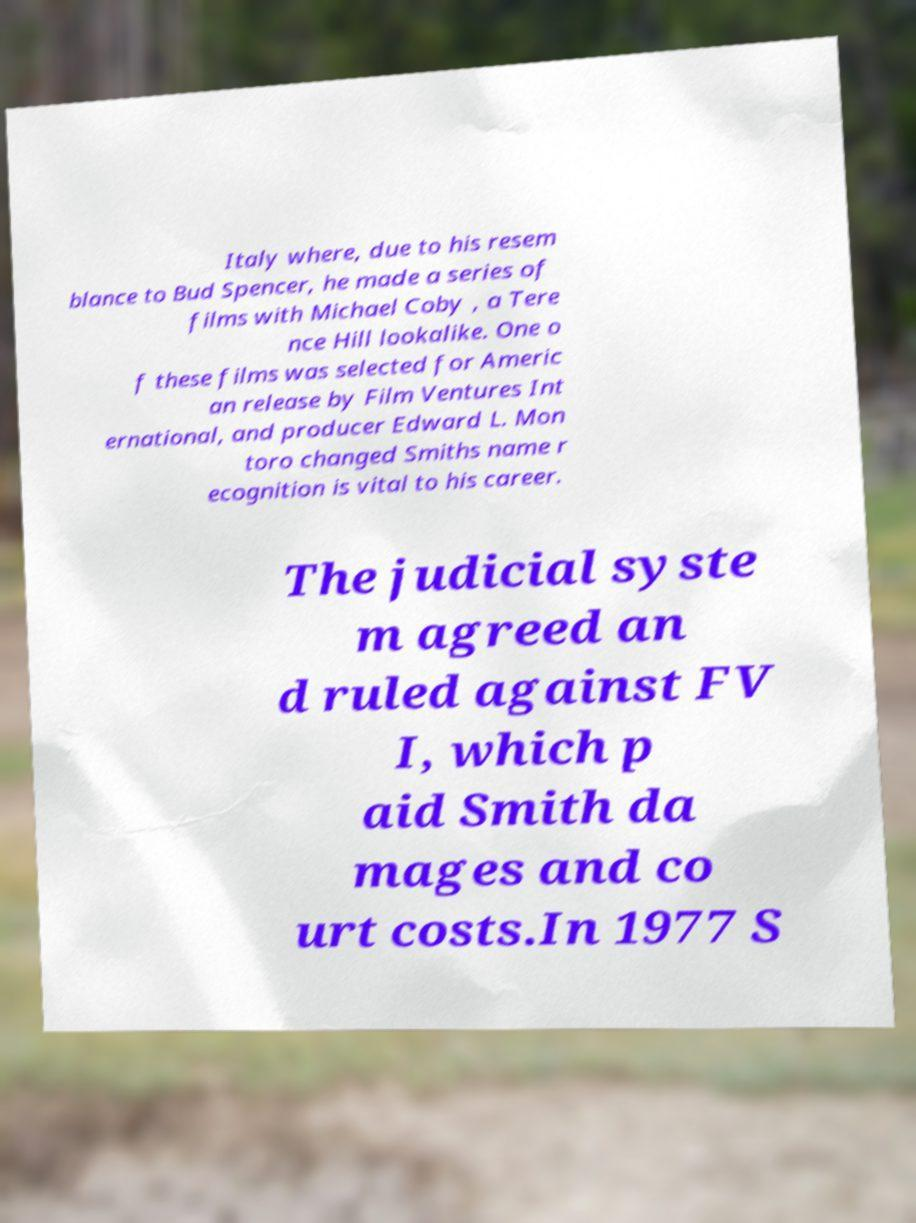Could you extract and type out the text from this image? Italy where, due to his resem blance to Bud Spencer, he made a series of films with Michael Coby , a Tere nce Hill lookalike. One o f these films was selected for Americ an release by Film Ventures Int ernational, and producer Edward L. Mon toro changed Smiths name r ecognition is vital to his career. The judicial syste m agreed an d ruled against FV I, which p aid Smith da mages and co urt costs.In 1977 S 